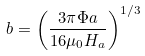<formula> <loc_0><loc_0><loc_500><loc_500>b = \left ( \frac { 3 \pi \Phi a } { 1 6 \mu _ { 0 } H _ { a } } \right ) ^ { 1 / 3 }</formula> 